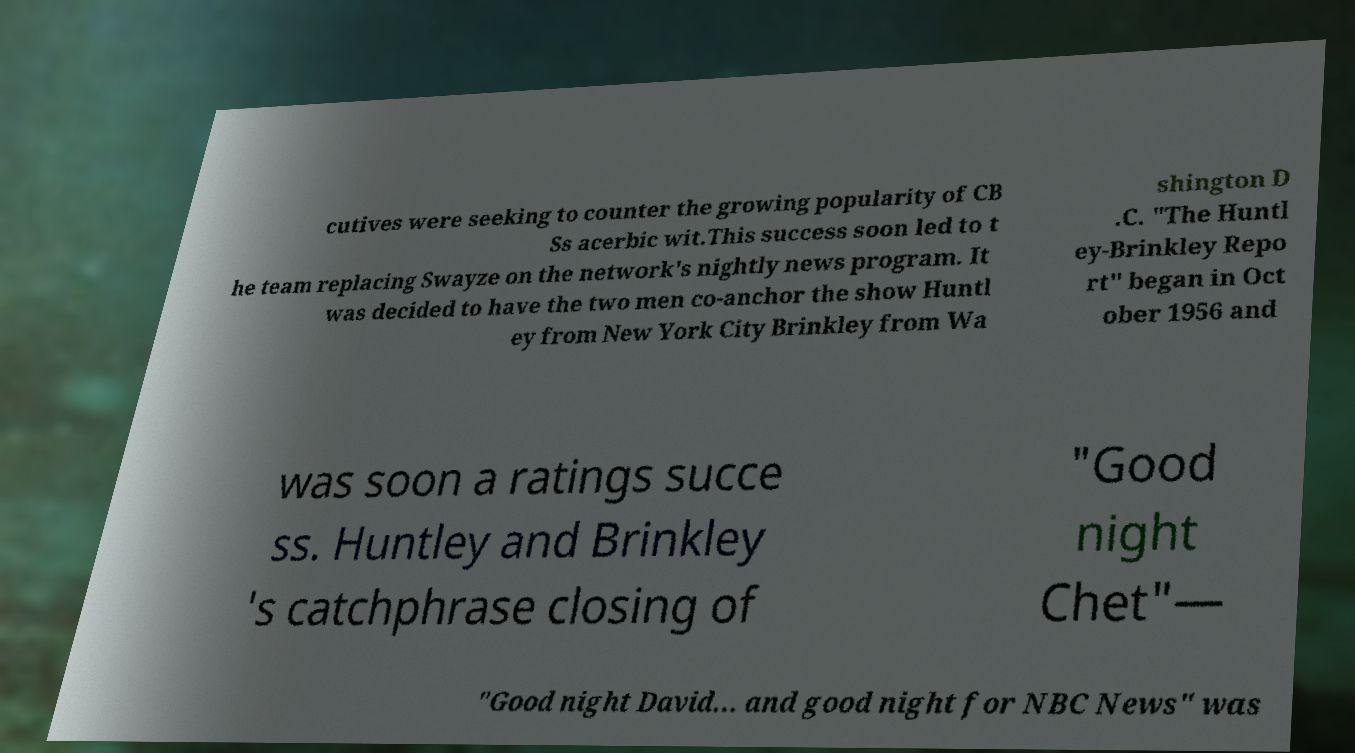I need the written content from this picture converted into text. Can you do that? cutives were seeking to counter the growing popularity of CB Ss acerbic wit.This success soon led to t he team replacing Swayze on the network's nightly news program. It was decided to have the two men co-anchor the show Huntl ey from New York City Brinkley from Wa shington D .C. "The Huntl ey-Brinkley Repo rt" began in Oct ober 1956 and was soon a ratings succe ss. Huntley and Brinkley 's catchphrase closing of "Good night Chet"— "Good night David... and good night for NBC News" was 